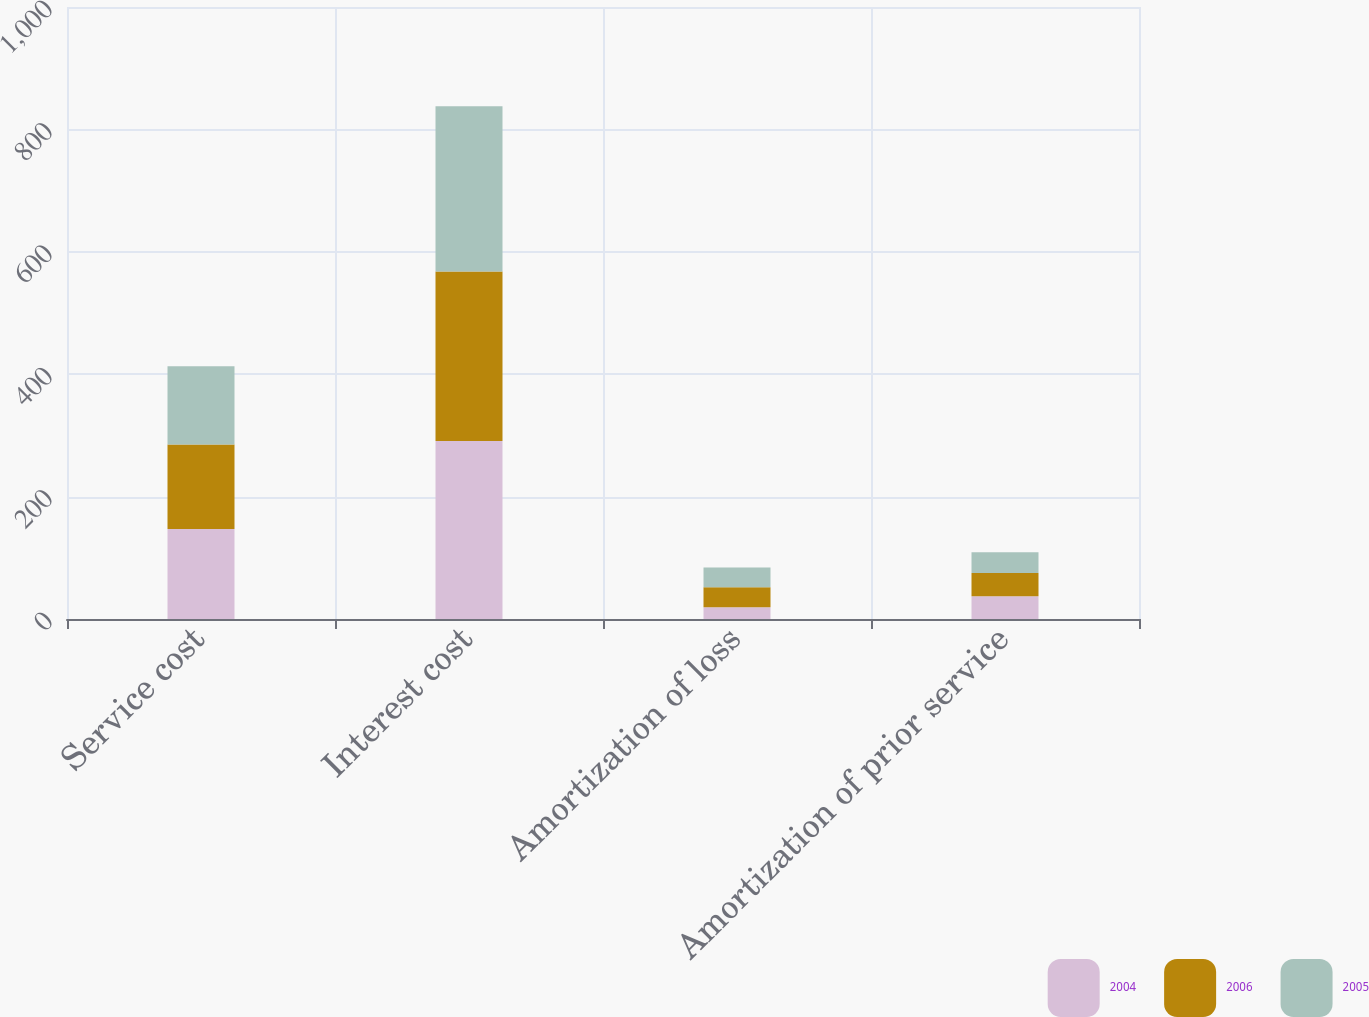Convert chart. <chart><loc_0><loc_0><loc_500><loc_500><stacked_bar_chart><ecel><fcel>Service cost<fcel>Interest cost<fcel>Amortization of loss<fcel>Amortization of prior service<nl><fcel>2004<fcel>147<fcel>291<fcel>19<fcel>37<nl><fcel>2006<fcel>138<fcel>277<fcel>33<fcel>38<nl><fcel>2005<fcel>128<fcel>270<fcel>32<fcel>34<nl></chart> 